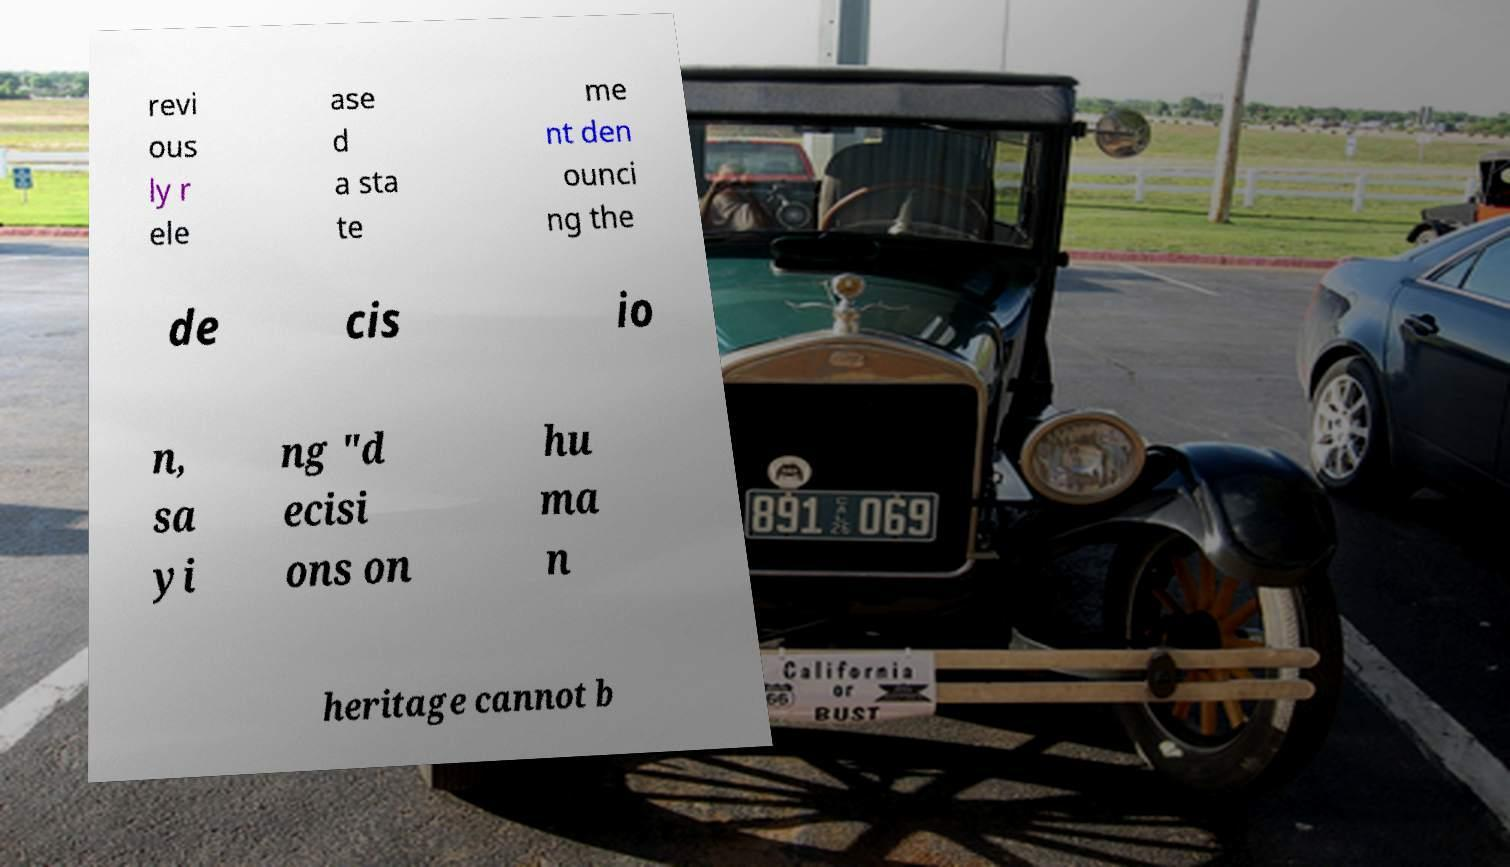Could you extract and type out the text from this image? revi ous ly r ele ase d a sta te me nt den ounci ng the de cis io n, sa yi ng "d ecisi ons on hu ma n heritage cannot b 